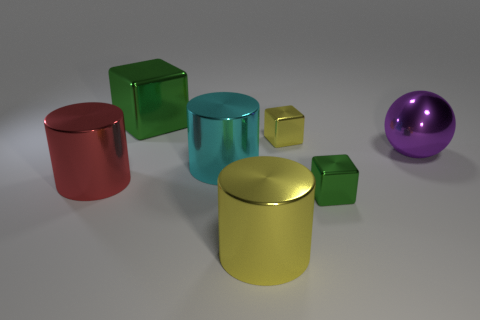There is a metal object behind the yellow shiny block; does it have the same color as the cube that is in front of the big red metallic cylinder?
Your answer should be very brief. Yes. Is the number of big things that are to the left of the purple metallic object greater than the number of big cyan things?
Your answer should be compact. Yes. There is a green thing that is behind the metallic sphere on the right side of the large metallic block; are there any objects right of it?
Give a very brief answer. Yes. Are there any blocks to the right of the big purple shiny sphere?
Provide a succinct answer. No. How many metal cylinders have the same color as the large ball?
Provide a short and direct response. 0. The red cylinder that is the same material as the large cyan cylinder is what size?
Give a very brief answer. Large. How big is the yellow metal object behind the green metal block that is right of the yellow metal thing that is in front of the big purple sphere?
Offer a terse response. Small. What is the size of the yellow thing that is behind the cyan cylinder?
Keep it short and to the point. Small. What number of blue objects are tiny cylinders or big shiny cylinders?
Your answer should be compact. 0. Is there a purple rubber ball that has the same size as the red object?
Provide a short and direct response. No. 